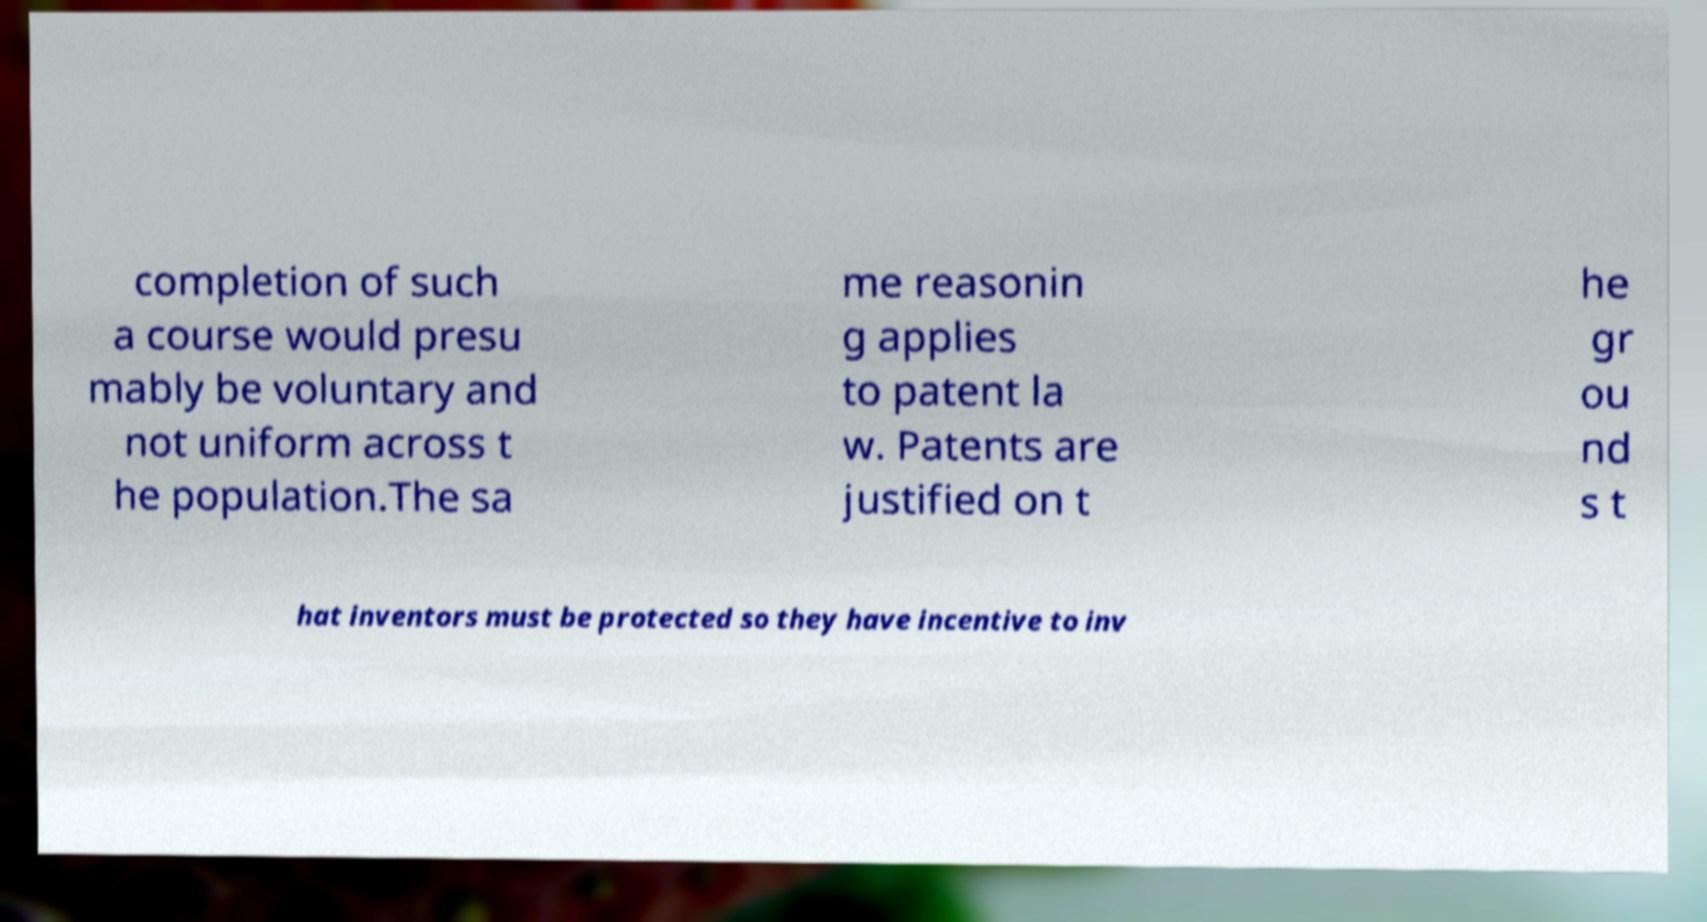What messages or text are displayed in this image? I need them in a readable, typed format. completion of such a course would presu mably be voluntary and not uniform across t he population.The sa me reasonin g applies to patent la w. Patents are justified on t he gr ou nd s t hat inventors must be protected so they have incentive to inv 